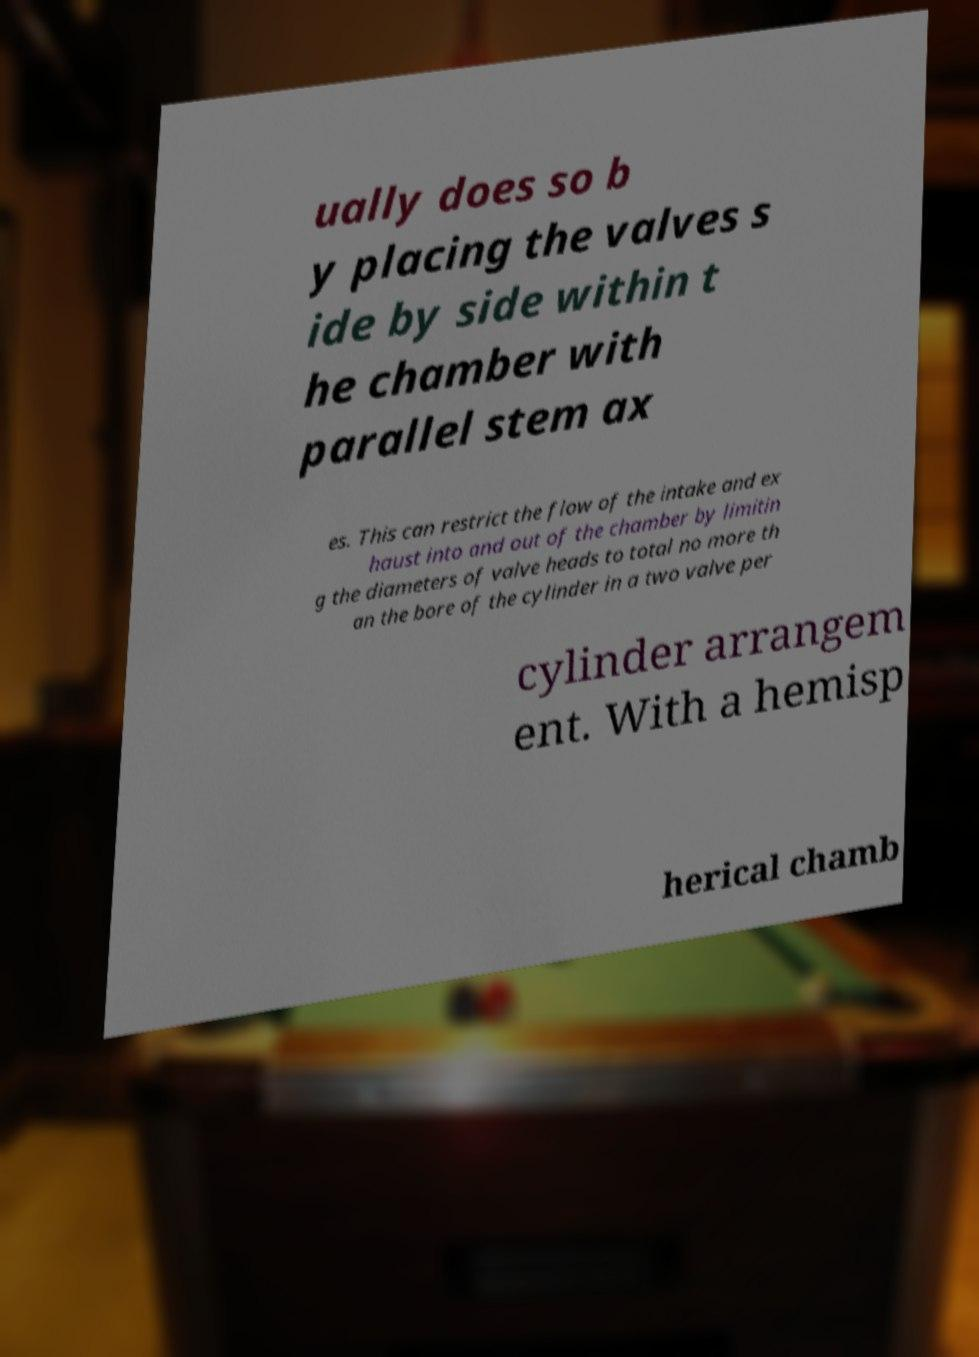There's text embedded in this image that I need extracted. Can you transcribe it verbatim? ually does so b y placing the valves s ide by side within t he chamber with parallel stem ax es. This can restrict the flow of the intake and ex haust into and out of the chamber by limitin g the diameters of valve heads to total no more th an the bore of the cylinder in a two valve per cylinder arrangem ent. With a hemisp herical chamb 